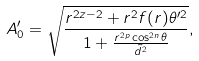<formula> <loc_0><loc_0><loc_500><loc_500>A ^ { \prime } _ { 0 } = \sqrt { \frac { r ^ { 2 z - 2 } + r ^ { 2 } f ( r ) \theta ^ { \prime 2 } } { 1 + \frac { r ^ { 2 p } \cos ^ { 2 n } \theta } { \tilde { d } ^ { 2 } } } } ,</formula> 